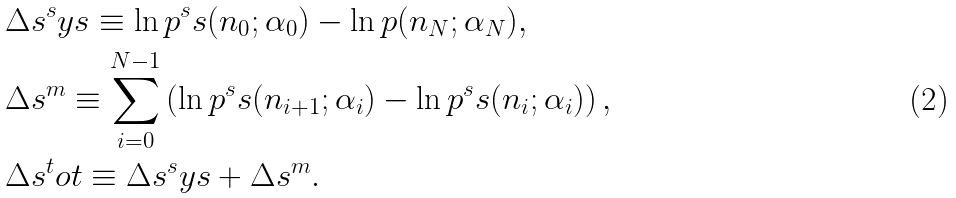Convert formula to latex. <formula><loc_0><loc_0><loc_500><loc_500>& \Delta s ^ { s } y s \equiv \ln p ^ { s } s ( n _ { 0 } ; \alpha _ { 0 } ) - \ln p ( n _ { N } ; \alpha _ { N } ) , \\ & \Delta s ^ { m } \equiv \sum _ { i = 0 } ^ { N - 1 } \left ( \ln p ^ { s } s ( n _ { i + 1 } ; \alpha _ { i } ) - \ln p ^ { s } s ( n _ { i } ; \alpha _ { i } ) \right ) , \\ & \Delta s ^ { t } o t \equiv \Delta s ^ { s } y s + \Delta s ^ { m } .</formula> 